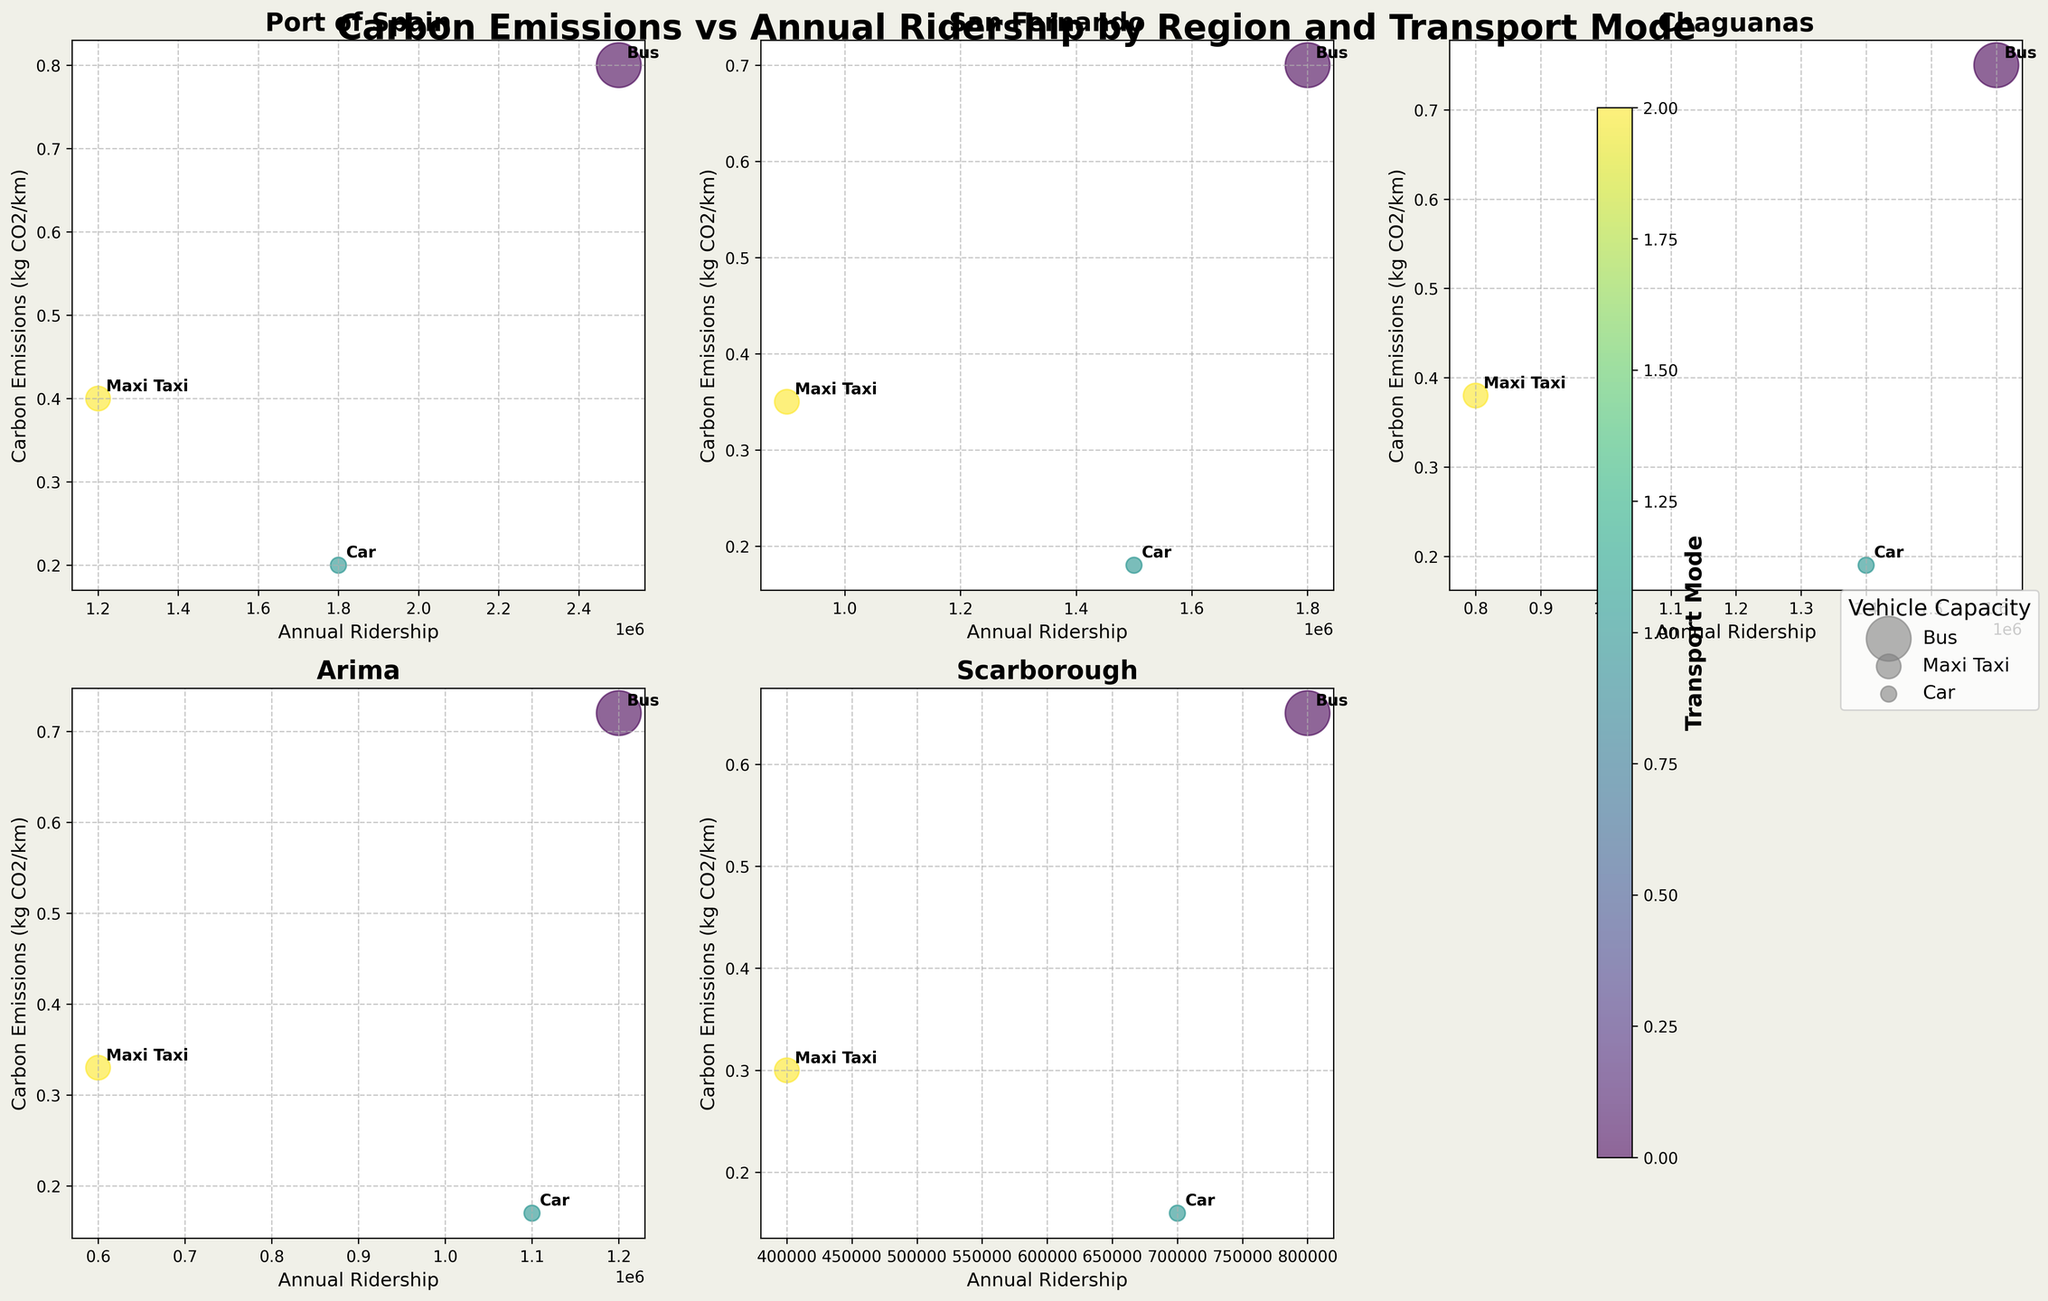How many regions are displayed in the subplot? Look at the titles of the individual subplots to count the number of distinct regions presented.
Answer: 5 What is the title of the overall figure? Check the main title at the top of the plot which summarizes the whole visualization.
Answer: Carbon Emissions vs Annual Ridership by Region and Transport Mode In which region do buses have the highest annual ridership? Look for the subplot titles and identify the bubble representing buses (likely the largest bubble) with the highest position in terms of annual ridership.
Answer: Port of Spain Which transport mode in Scarborough has the lowest carbon emissions per kilometer? In the subplot titled "Scarborough," find the bubble for each transport mode and note the one positioned lowest on the y-axis.
Answer: Car What is the approximate annual ridership for maxi taxis in Chaguanas? In the subplot titled "Chaguanas," locate the bubble for maxi taxis and read its position on the x-axis.
Answer: 800,000 How do the carbon emissions per kilometer for cars in Port of Spain compare to those in Arima? Check the y-axis positions of the car bubbles in the subplots for Port of Spain and Arima to see which one is higher.
Answer: Port of Spain > Arima Which region has the largest variation in carbon emissions among different transport modes? Compare the vertical spread of the bubbles within each region's subplot to determine which one has the widest range.
Answer: Port of Spain What's the relationship between vehicle capacity and bubble size? Observe the different bubble sizes for buses, maxi taxis, and cars, and correlate them with their given vehicle capacities.
Answer: Larger vehicle capacity results in larger bubble size Which region's buses have the lowest carbon emissions per kilometer? In each subplot, find the bubble representing buses and identify the lowest position on the y-axis.
Answer: Scarborough Do higher ridership numbers generally correspond to higher or lower carbon emissions per kilometer? Look at the overall trend in bubble positions across all subplots, comparing higher x-axis values (ridership) to their corresponding y-axis values (carbon emissions).
Answer: Generally lower 